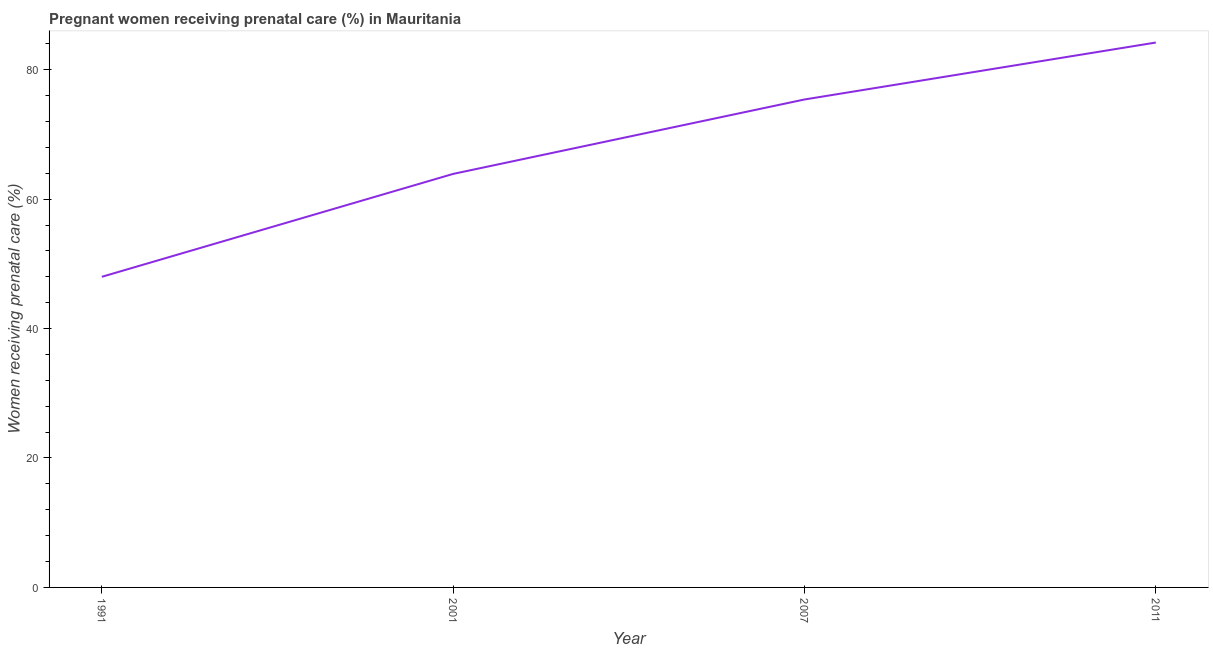What is the percentage of pregnant women receiving prenatal care in 2011?
Offer a terse response. 84.2. Across all years, what is the maximum percentage of pregnant women receiving prenatal care?
Your response must be concise. 84.2. Across all years, what is the minimum percentage of pregnant women receiving prenatal care?
Offer a very short reply. 48. In which year was the percentage of pregnant women receiving prenatal care minimum?
Provide a short and direct response. 1991. What is the sum of the percentage of pregnant women receiving prenatal care?
Your response must be concise. 271.5. What is the difference between the percentage of pregnant women receiving prenatal care in 2007 and 2011?
Give a very brief answer. -8.8. What is the average percentage of pregnant women receiving prenatal care per year?
Provide a short and direct response. 67.88. What is the median percentage of pregnant women receiving prenatal care?
Provide a short and direct response. 69.65. Do a majority of the years between 2007 and 1991 (inclusive) have percentage of pregnant women receiving prenatal care greater than 52 %?
Make the answer very short. No. What is the ratio of the percentage of pregnant women receiving prenatal care in 2001 to that in 2011?
Your answer should be compact. 0.76. What is the difference between the highest and the second highest percentage of pregnant women receiving prenatal care?
Ensure brevity in your answer.  8.8. Is the sum of the percentage of pregnant women receiving prenatal care in 2001 and 2007 greater than the maximum percentage of pregnant women receiving prenatal care across all years?
Ensure brevity in your answer.  Yes. What is the difference between the highest and the lowest percentage of pregnant women receiving prenatal care?
Ensure brevity in your answer.  36.2. How many lines are there?
Make the answer very short. 1. What is the difference between two consecutive major ticks on the Y-axis?
Give a very brief answer. 20. Are the values on the major ticks of Y-axis written in scientific E-notation?
Your answer should be very brief. No. What is the title of the graph?
Ensure brevity in your answer.  Pregnant women receiving prenatal care (%) in Mauritania. What is the label or title of the X-axis?
Offer a very short reply. Year. What is the label or title of the Y-axis?
Offer a terse response. Women receiving prenatal care (%). What is the Women receiving prenatal care (%) of 2001?
Your answer should be very brief. 63.9. What is the Women receiving prenatal care (%) of 2007?
Your answer should be very brief. 75.4. What is the Women receiving prenatal care (%) in 2011?
Your answer should be compact. 84.2. What is the difference between the Women receiving prenatal care (%) in 1991 and 2001?
Make the answer very short. -15.9. What is the difference between the Women receiving prenatal care (%) in 1991 and 2007?
Give a very brief answer. -27.4. What is the difference between the Women receiving prenatal care (%) in 1991 and 2011?
Your response must be concise. -36.2. What is the difference between the Women receiving prenatal care (%) in 2001 and 2011?
Your answer should be compact. -20.3. What is the ratio of the Women receiving prenatal care (%) in 1991 to that in 2001?
Make the answer very short. 0.75. What is the ratio of the Women receiving prenatal care (%) in 1991 to that in 2007?
Ensure brevity in your answer.  0.64. What is the ratio of the Women receiving prenatal care (%) in 1991 to that in 2011?
Keep it short and to the point. 0.57. What is the ratio of the Women receiving prenatal care (%) in 2001 to that in 2007?
Make the answer very short. 0.85. What is the ratio of the Women receiving prenatal care (%) in 2001 to that in 2011?
Your response must be concise. 0.76. What is the ratio of the Women receiving prenatal care (%) in 2007 to that in 2011?
Provide a short and direct response. 0.9. 